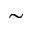Convert formula to latex. <formula><loc_0><loc_0><loc_500><loc_500>\sim</formula> 